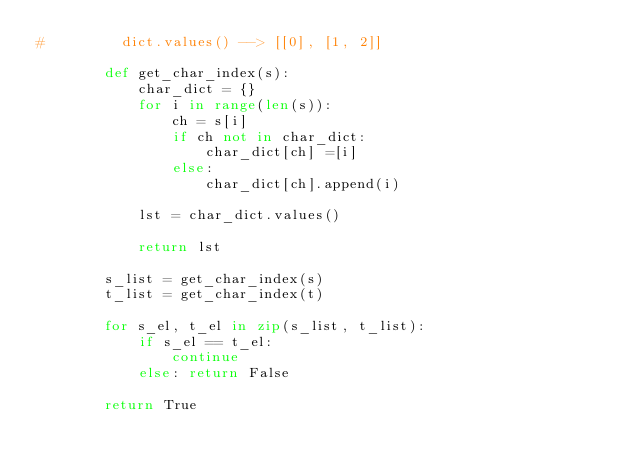<code> <loc_0><loc_0><loc_500><loc_500><_Python_>#         dict.values() --> [[0], [1, 2]]
                
        def get_char_index(s):         
            char_dict = {}
            for i in range(len(s)):
                ch = s[i] 
                if ch not in char_dict:
                    char_dict[ch] =[i]
                else:
                    char_dict[ch].append(i)
            
            lst = char_dict.values()

            return lst
        
        s_list = get_char_index(s)
        t_list = get_char_index(t)
        
        for s_el, t_el in zip(s_list, t_list):
            if s_el == t_el:
                continue
            else: return False
        
        return True</code> 